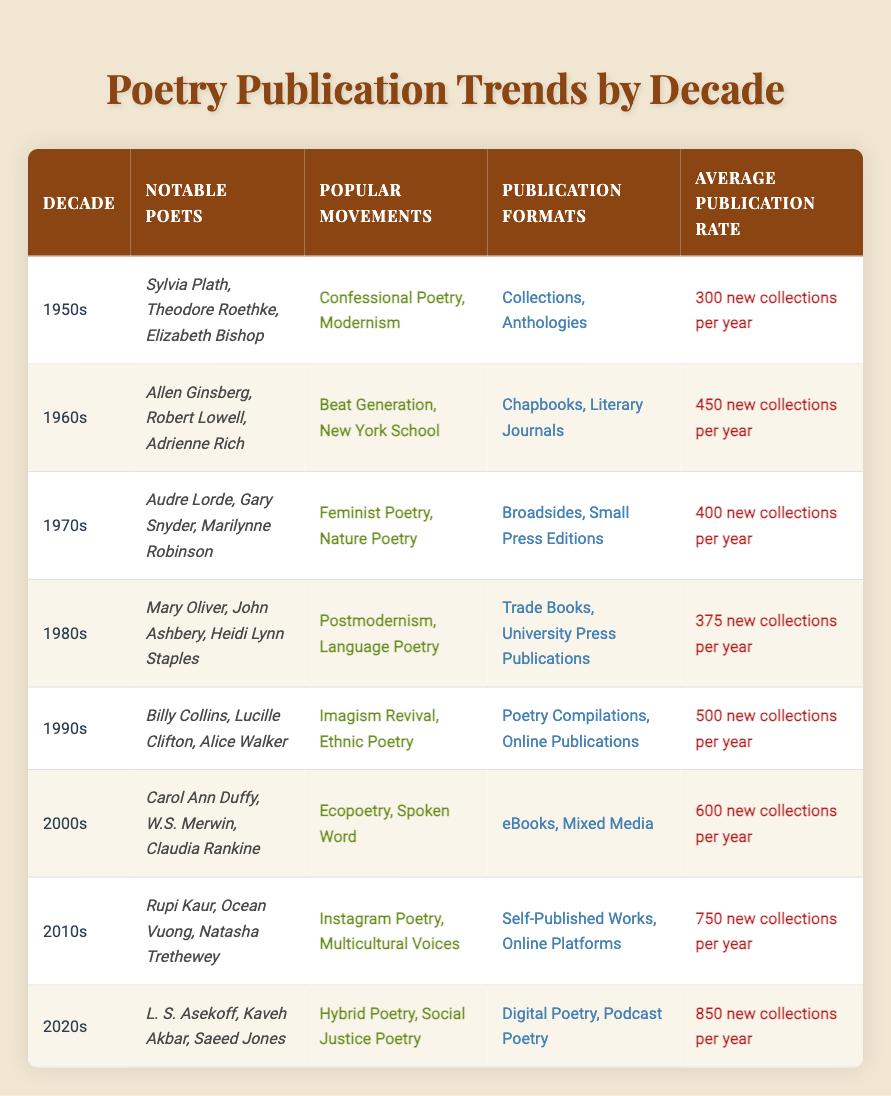What notable poets emerged in the 1990s? The table lists "Billy Collins, Lucille Clifton, Alice Walker" as notable poets from the 1990s.
Answer: Billy Collins, Lucille Clifton, Alice Walker Which decade saw the highest average publication rate of new collections? By comparing the average publication rates from each decade, the 2020s have the highest rate at "850 new collections per year."
Answer: 2020s Is the confessional poetry movement associated with the 1950s? The table specifies that "Confessional Poetry" was one of the popular movements during the 1950s, making the statement true.
Answer: Yes How many notable poets are mentioned for the 2000s? The entry for the 2000s lists three notable poets: "Carol Ann Duffy, W.S. Merwin, Claudia Rankine."
Answer: 3 What was the average publication rate in the 1980s compared to the 1970s? The average publication rate for the 1980s is "375 new collections per year," while for the 1970s, it is "400 new collections per year." The 1970s had a higher average by 25 collections.
Answer: 25 collections Which movements correspond to the notable poets of the 2010s? The table indicates that notable poets from the 2010s were associated with "Instagram Poetry" and "Multicultural Voices."
Answer: Instagram Poetry, Multicultural Voices Did the 1960s have more publication formats than the 1980s? The 1960s had two formats, "Chapbooks" and "Literary Journals," while the 1980s had also two formats, "Trade Books" and "University Press Publications," making the number equal.
Answer: No Which decade appears to have experienced a growth in publication formats when comparing the 1990s to the 2000s? The 1990s were associated with "Poetry Compilations" and "Online Publications," totaling two formats, while the 2000s had "eBooks" and "Mixed Media," also totaling two formats. Neither decade experienced a growth in publication formats, as both had two.
Answer: No 